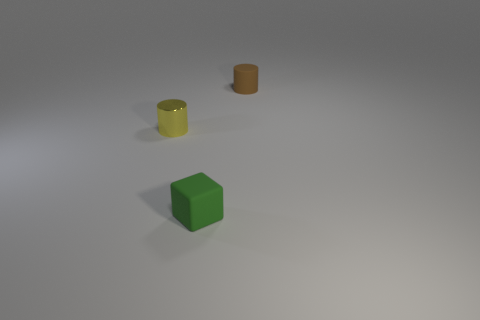Subtract all cubes. How many objects are left? 2 Add 1 small green cubes. How many objects exist? 4 Subtract all cyan cubes. Subtract all blue cylinders. How many cubes are left? 1 Subtract all yellow shiny cylinders. Subtract all blue rubber cylinders. How many objects are left? 2 Add 1 tiny yellow metallic cylinders. How many tiny yellow metallic cylinders are left? 2 Add 2 small brown cylinders. How many small brown cylinders exist? 3 Subtract 0 blue cylinders. How many objects are left? 3 